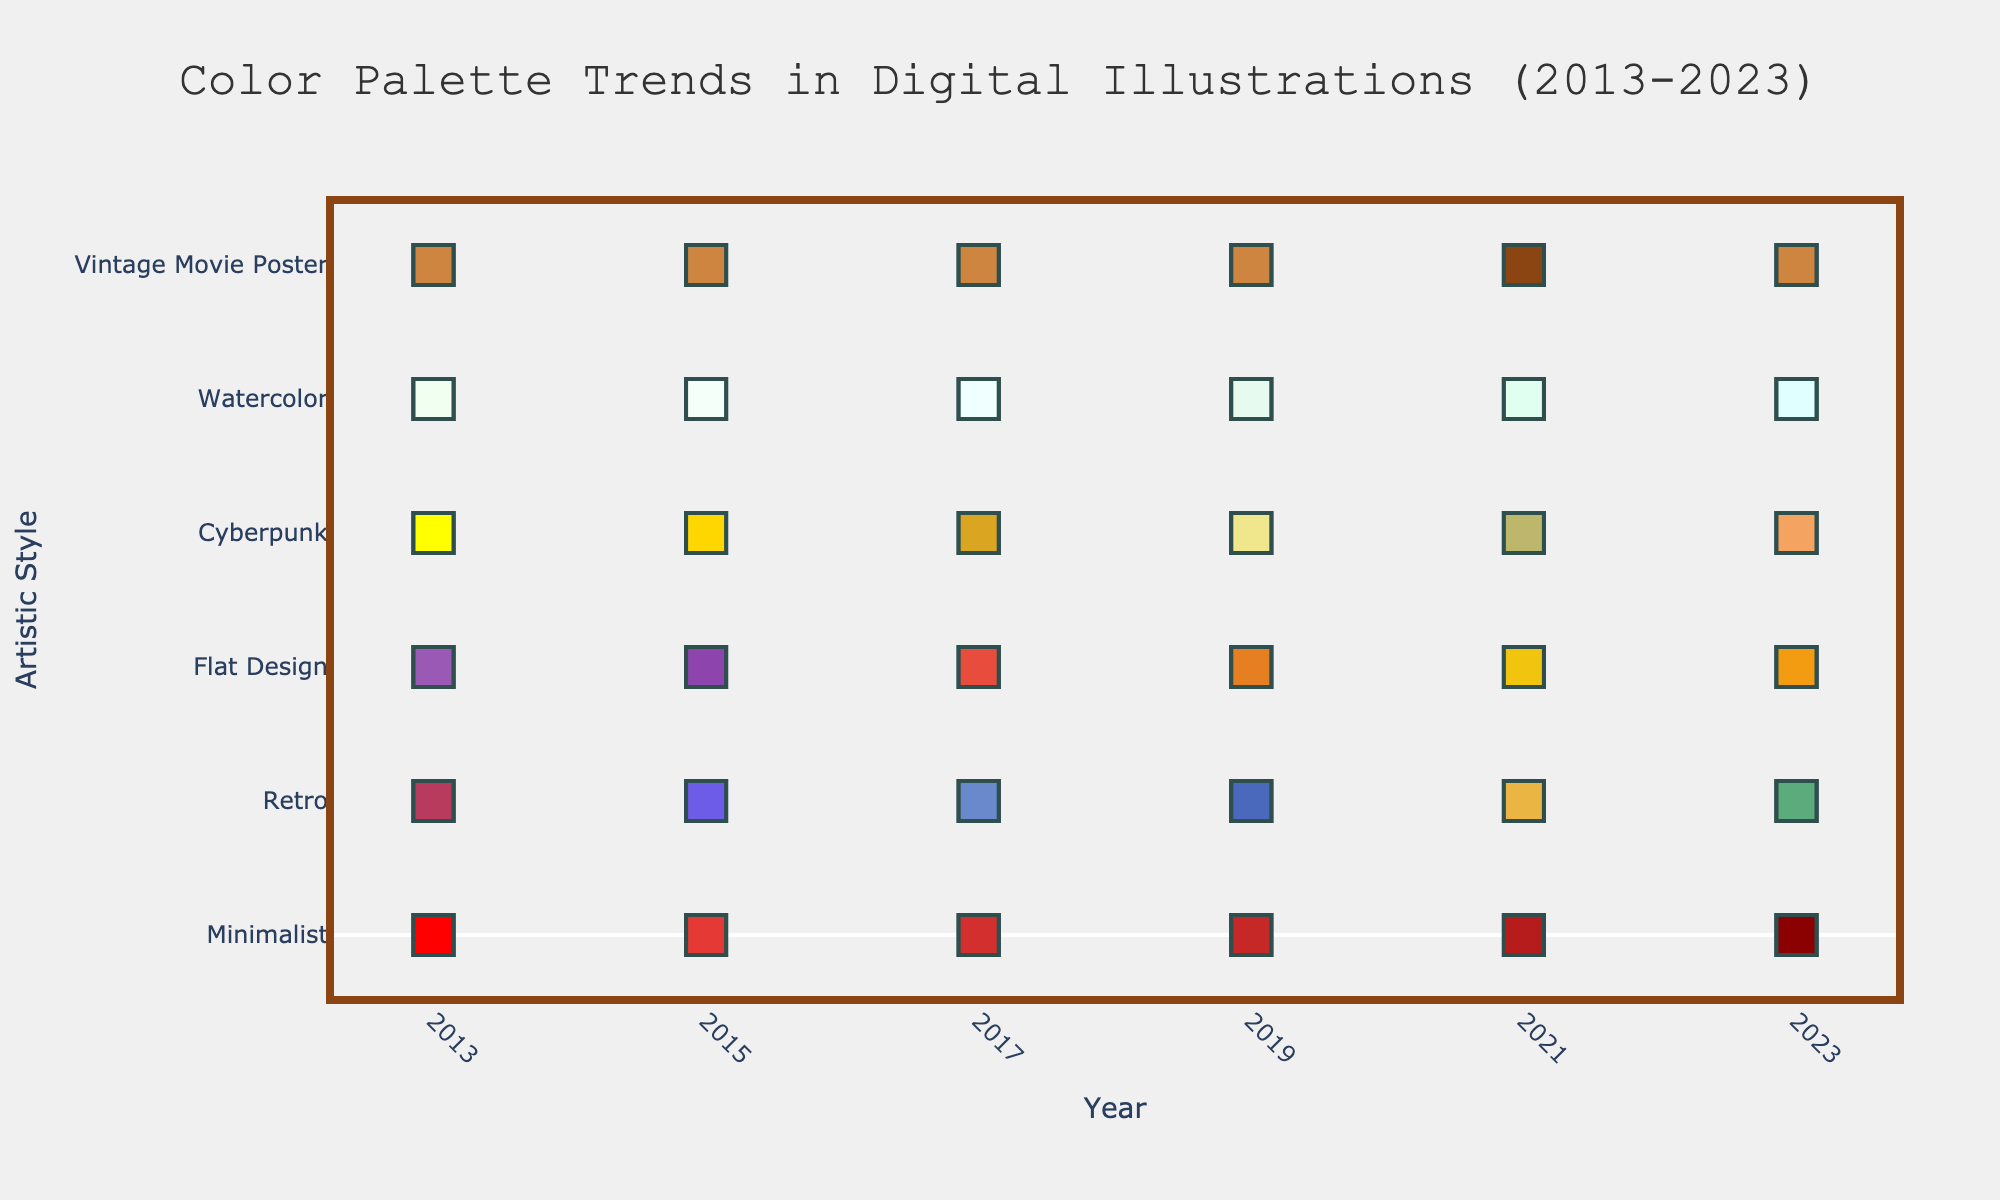what are the artistic styles shown in the figure? The artistic styles are listed on the y-axis of the figure. From top to bottom, they are: Minimalist, Retro, Flat Design, Cyberpunk, Watercolor, and Vintage Movie Poster.
Answer: Minimalist, Retro, Flat Design, Cyberpunk, Watercolor, Vintage Movie Poster what is the title of the figure? The title of the figure is located at the top and centered. The text reads "Color Palette Trends in Digital Illustrations (2013-2023)".
Answer: Color Palette Trends in Digital Illustrations (2013-2023) how many different color palettes are shown for each artistic style? Each artistic style has three color palettes shown, as evident by the three different colors representing different parts of the color palette for each style across the years.
Answer: 3 which artistic style uses the least variation in color between 2013 and 2023? By visually inspecting the color changes for each artistic style over the years, the Vintage Movie Poster style shows the least variation, sticking with similar shades of brown.
Answer: Vintage Movie Poster In which year did the Retro style use the color combination of #F9ED69, #F08A5D, and #B83B5E? Review the color markers for Retro. The described colors are used in the year 2013.
Answer: 2013 which two artistic styles have their palette containing a shade of red (#FF0000) in 2013? Check the color markers for each style in 2013. Both Minimalist (#FF0000) and Retro (#B83B5E) have shades of red in their 2013 palette.
Answer: Minimalist, Retro between 2013 and 2023, which artistic style shows the most drastic color shift? By comparing the color changes across years, Cyberpunk shows the most drastic shift with significant changes from bright neon colors to pastel shades.
Answer: Cyberpunk how do the color trends for the Minimalist and Flat Design styles compare between 2013 and 2023? Examine the color changes for both styles. Minimalist changes slowly towards darker shades, while Flat Design shifts dynamically with both contrasting colors and evolving color trends.
Answer: Minimalist: gradual darkening, Flat Design: dynamic changes what color did the Cyberpunk style use in 2021 that's not present in prior years? Look at the color markers for Cyberpunk in 2021. The color used in 2021 but not before is #BDB76B.
Answer: #BDB76B which artistic style maintained a consistent use of a shade of blue across the decade? Examine the markers for consistency in blue shades. Flat Design consistently includes shades of blue (e.g., #3498DB, #2980B9, #2C3E50, #34495E, #4834D4, #130F40).
Answer: Flat Design 